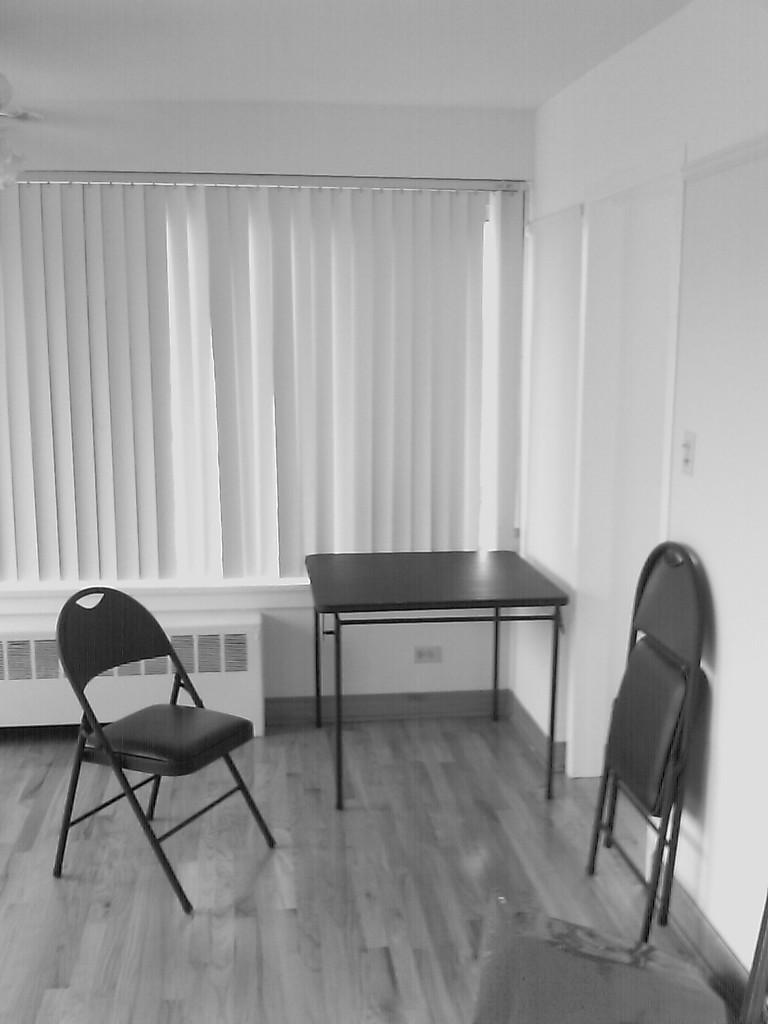Describe this image in one or two sentences. In the image we can see two chairs and a table. This is a floor and a window. 